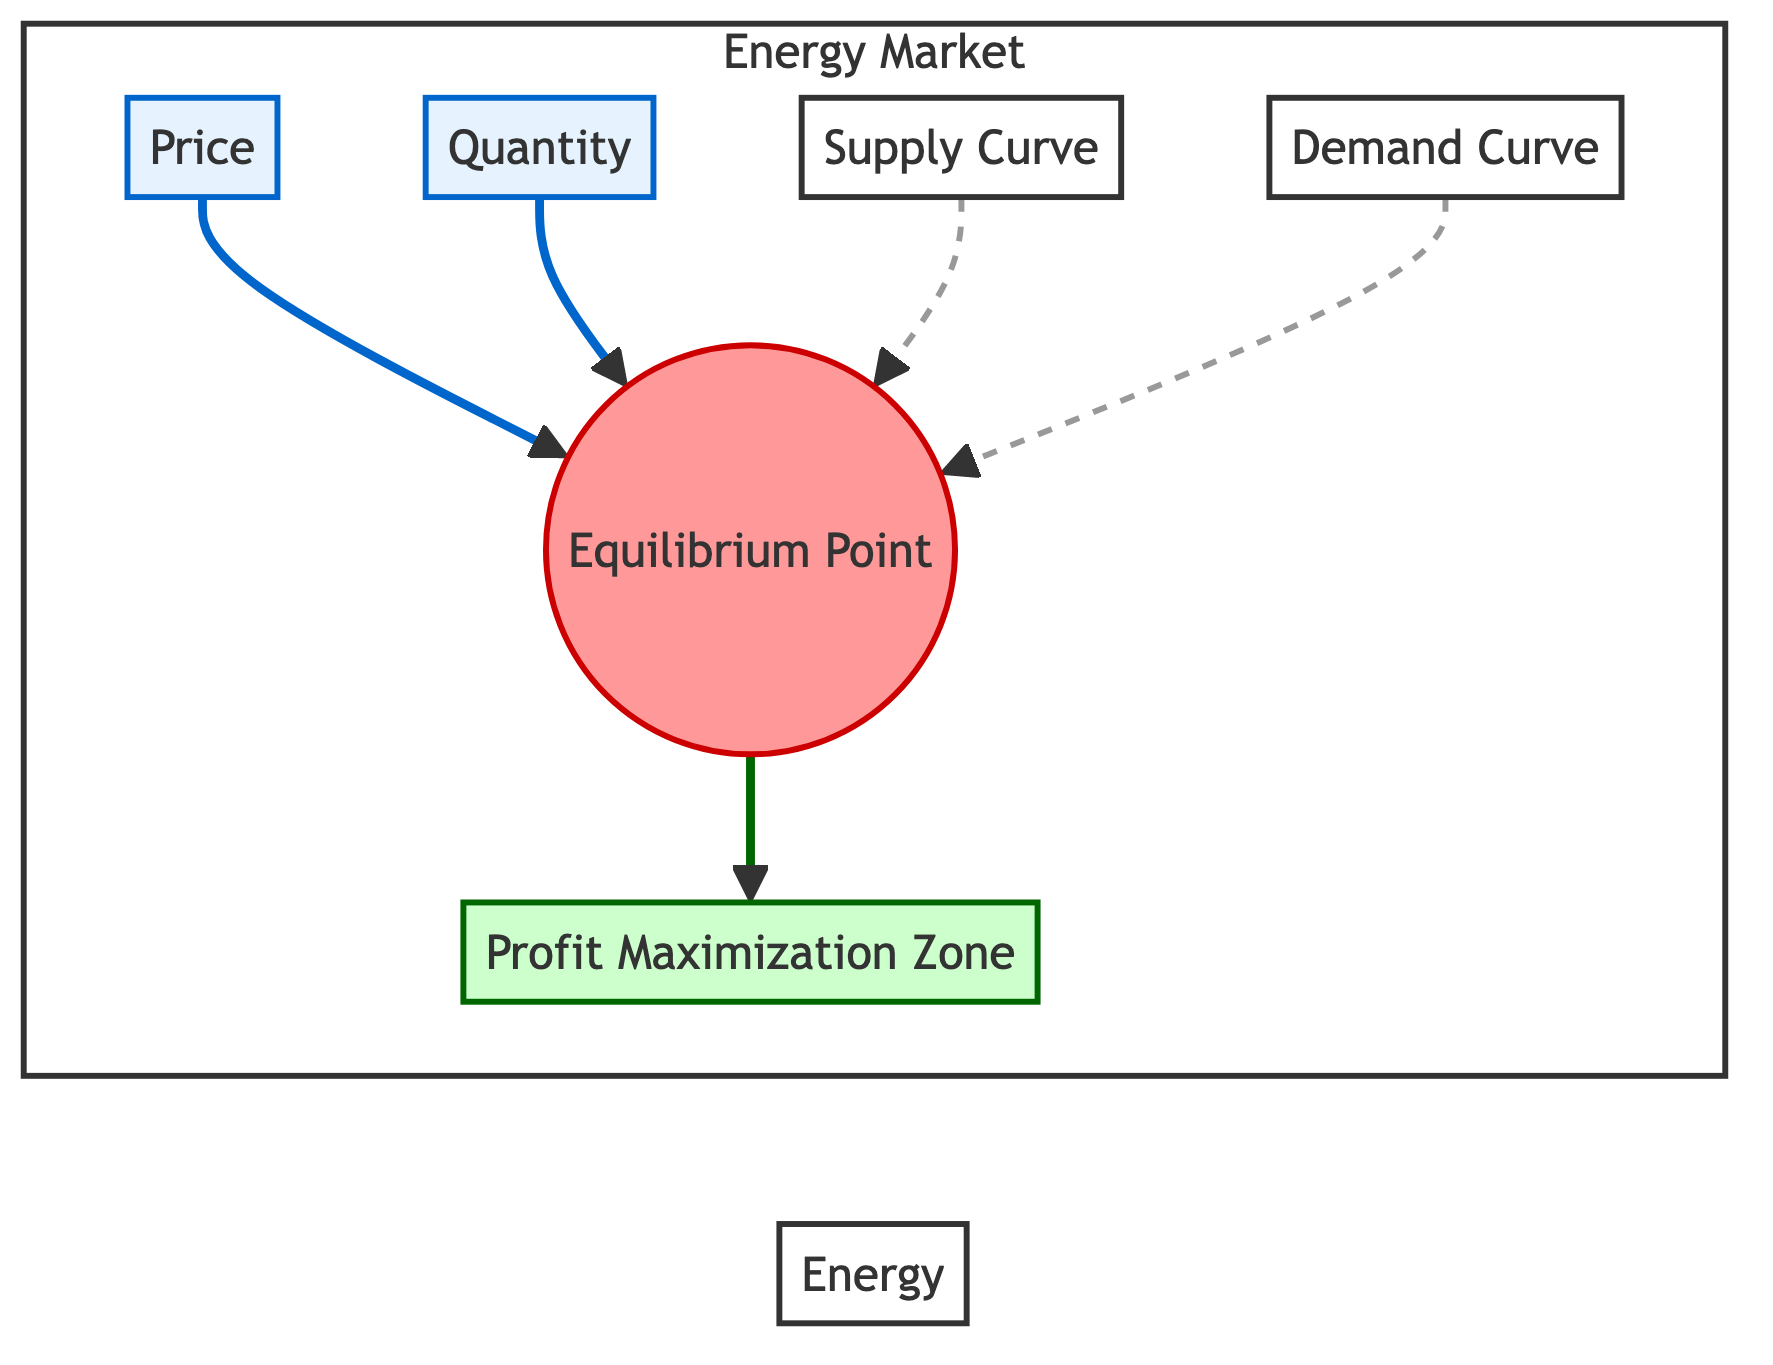What does EP represent? EP stands for the Equilibrium Point, which is the intersection of the Supply and Demand Curves in the energy market indicating the price and quantity where supply equals demand.
Answer: Equilibrium Point How many curves are displayed in the diagram? The diagram shows two curves: the Supply Curve and the Demand Curve, both of which converge at the Equilibrium Point.
Answer: Two Which area indicates profit maximization? The Profit Maximization Zone (PMZ) is highlighted in the diagram as a zone showing the area where producers maximize their profits based on price and quantity.
Answer: Profit Maximization Zone What relationship do the Supply and Demand Curves have at the Equilibrium Point? At the Equilibrium Point, the Supply Curve and Demand Curve intersect, indicating that the quantity supplied is equal to the quantity demanded at the market equilibrium price.
Answer: They intersect What does the dashed line represent in the diagram? The dashed line represents the relationship of demand and supply leading to the Equilibrium Point, emphasizing their respective movements toward each other to establish market equilibrium.
Answer: Relationship of demand and supply If price increases, what effect do you expect on quantity demanded based on the diagram? An increase in price typically results in a decrease in quantity demanded, following the law of demand which suggests an inverse relationship between price and demand.
Answer: Decrease How would a shift in the Demand Curve affect the Equilibrium Point? A shift in the Demand Curve would change the position of the Equilibrium Point by either increasing or decreasing the equilibrium price and quantity, depending on whether demand increases or decreases.
Answer: Change in position What scenario might lead to the Profit Maximization Zone being affected? Changes in factors such as increased production costs or changes in consumer preferences could affect the Profit Maximization Zone by altering supply or demand conditions.
Answer: Changes in costs/preferences What is indicated by the arrows pointing towards the Equilibrium Point? The arrows point towards the Equilibrium Point to represent the dynamic movement of supply and demand in the market, indicating that the market forces are working towards achieving equilibrium.
Answer: Market forces toward equilibrium 